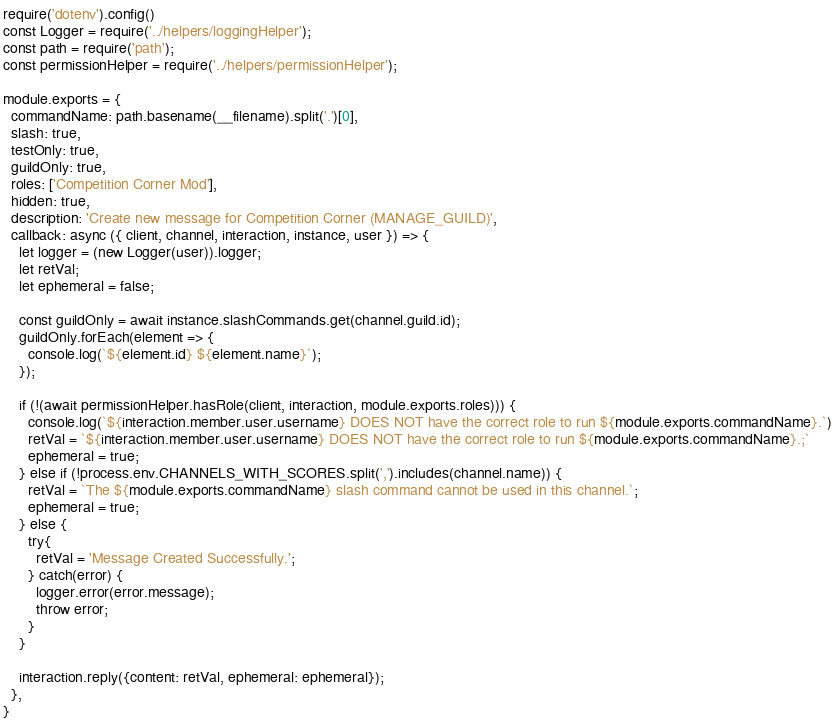<code> <loc_0><loc_0><loc_500><loc_500><_JavaScript_>require('dotenv').config()
const Logger = require('../helpers/loggingHelper');
const path = require('path');
const permissionHelper = require('../helpers/permissionHelper');

module.exports = {
  commandName: path.basename(__filename).split('.')[0],
  slash: true,
  testOnly: true,
  guildOnly: true,
  roles: ['Competition Corner Mod'],
  hidden: true,
  description: 'Create new message for Competition Corner (MANAGE_GUILD)',
  callback: async ({ client, channel, interaction, instance, user }) => {
    let logger = (new Logger(user)).logger;
    let retVal;
    let ephemeral = false;

    const guildOnly = await instance.slashCommands.get(channel.guild.id);
    guildOnly.forEach(element => {
      console.log(`${element.id} ${element.name}`);
    });

    if (!(await permissionHelper.hasRole(client, interaction, module.exports.roles))) {
      console.log(`${interaction.member.user.username} DOES NOT have the correct role to run ${module.exports.commandName}.`)
      retVal = `${interaction.member.user.username} DOES NOT have the correct role to run ${module.exports.commandName}.;`
      ephemeral = true;
    } else if (!process.env.CHANNELS_WITH_SCORES.split(',').includes(channel.name)) {
      retVal = `The ${module.exports.commandName} slash command cannot be used in this channel.`;
      ephemeral = true;
    } else {
      try{
        retVal = 'Message Created Successfully.';
      } catch(error) {
        logger.error(error.message);
        throw error;
      }
    }

    interaction.reply({content: retVal, ephemeral: ephemeral});
  },
}
</code> 